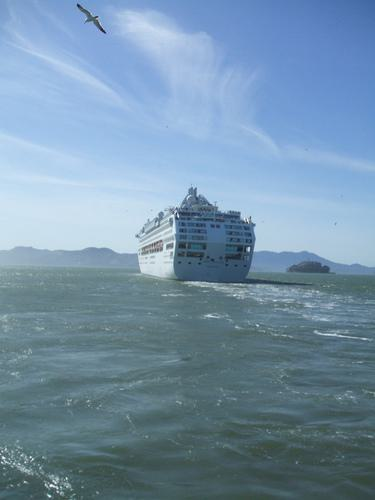Can you describe the environment around the ship? The ship is surrounded by open waters, likely an ocean or a large sea. The water is relatively calm with minor ripples, and in the distance, we can see a gentle coastline with what might be hills or small mountains. The sky is mostly clear with a few scattered clouds, suggesting fair weather for sailing.  What time of day does it seem to be? Based on the lighting and the shadows cast by the ship, it appears to be midday. The sun is high, casting bright light that enhances the white exterior of the cruise ship and gives the sea a sparkling appearance. 